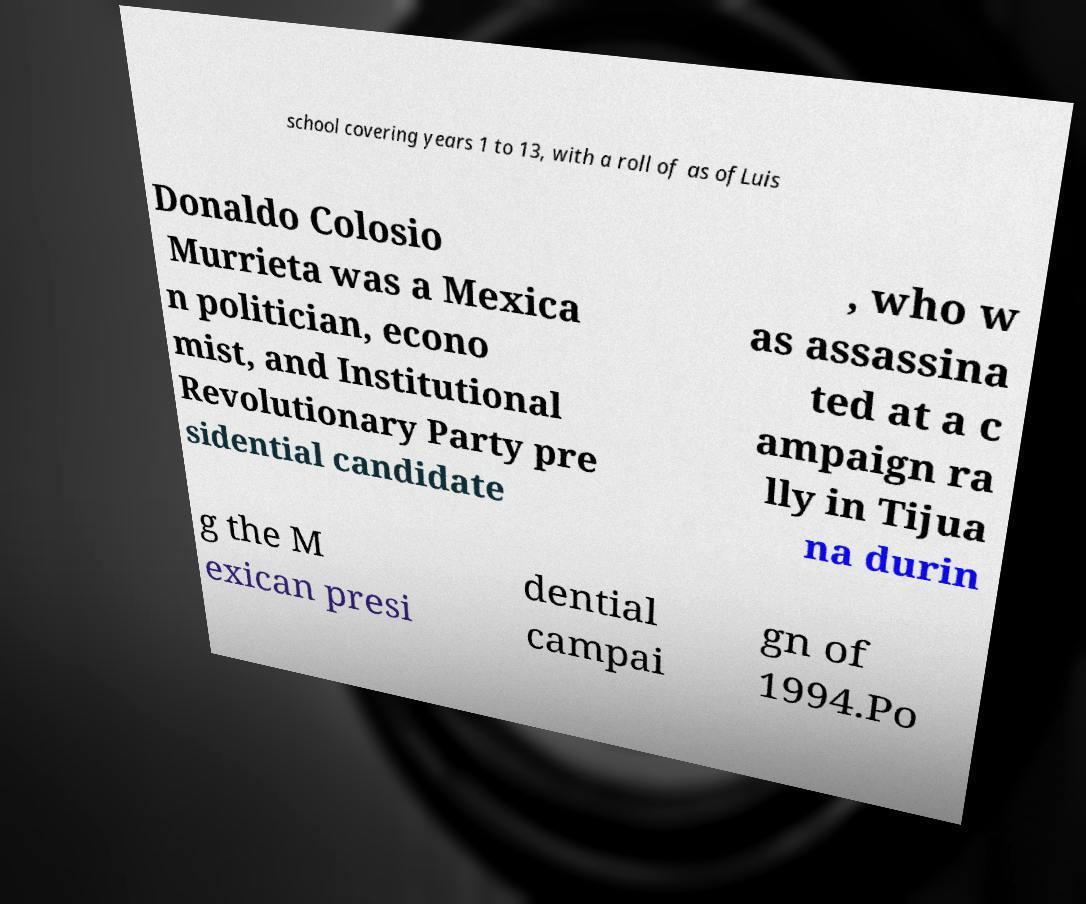I need the written content from this picture converted into text. Can you do that? school covering years 1 to 13, with a roll of as ofLuis Donaldo Colosio Murrieta was a Mexica n politician, econo mist, and Institutional Revolutionary Party pre sidential candidate , who w as assassina ted at a c ampaign ra lly in Tijua na durin g the M exican presi dential campai gn of 1994.Po 